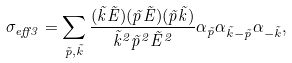Convert formula to latex. <formula><loc_0><loc_0><loc_500><loc_500>\sigma _ { e f f 3 } = \sum _ { \vec { p } , \vec { k } } \frac { ( \vec { k } \vec { E } ) ( \vec { p } \vec { E } ) ( \vec { p } \vec { k } ) } { \vec { k } ^ { 2 } \vec { p } ^ { 2 } \vec { E } ^ { 2 } } \alpha _ { \vec { p } } \alpha _ { \vec { k } - \vec { p } } \alpha _ { - \vec { k } } ,</formula> 